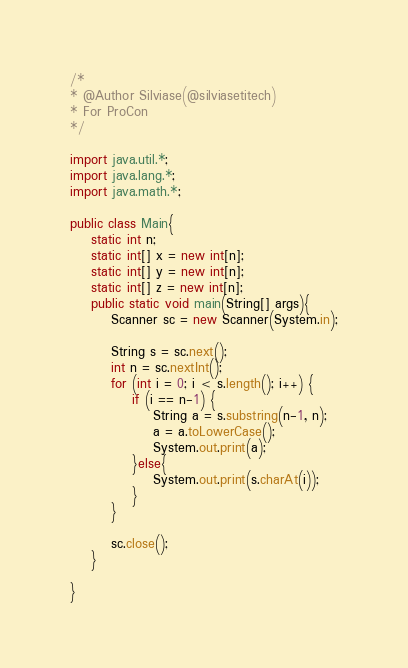<code> <loc_0><loc_0><loc_500><loc_500><_Java_>/*
* @Author Silviase(@silviasetitech)
* For ProCon
*/

import java.util.*;
import java.lang.*;
import java.math.*;

public class Main{    
    static int n;
    static int[] x = new int[n];
    static int[] y = new int[n];
    static int[] z = new int[n];
    public static void main(String[] args){
        Scanner sc = new Scanner(System.in);

        String s = sc.next();
        int n = sc.nextInt();
        for (int i = 0; i < s.length(); i++) {
            if (i == n-1) {
                String a = s.substring(n-1, n);
                a = a.toLowerCase();
                System.out.print(a);
            }else{
                System.out.print(s.charAt(i));
            }
        }

        sc.close();
    }

}
</code> 